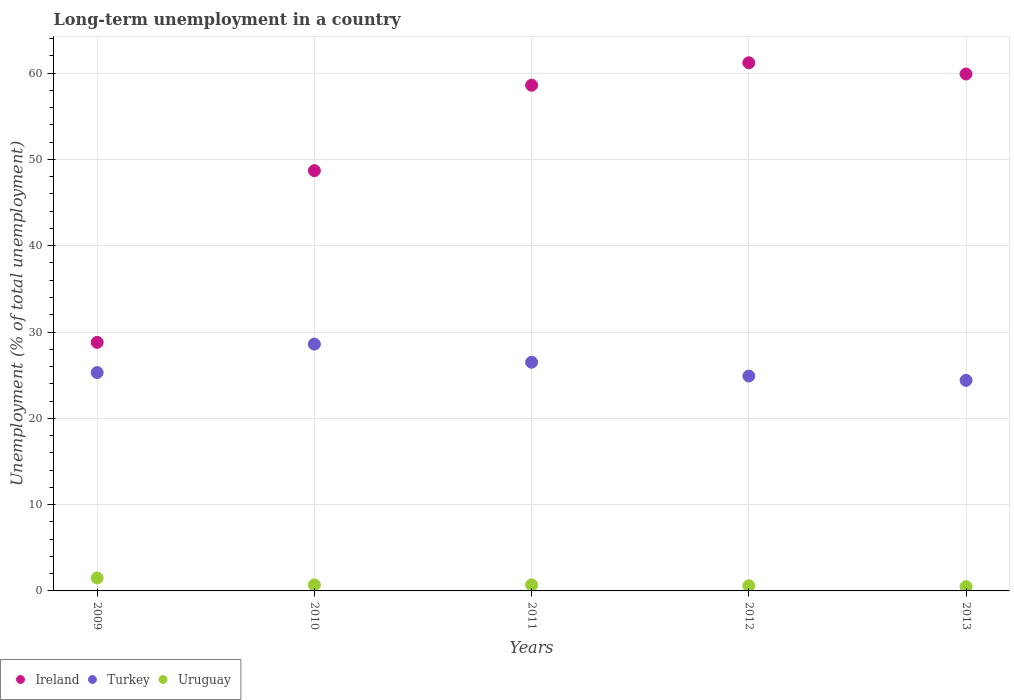What is the percentage of long-term unemployed population in Ireland in 2013?
Offer a very short reply. 59.9. Across all years, what is the maximum percentage of long-term unemployed population in Turkey?
Provide a short and direct response. 28.6. Across all years, what is the minimum percentage of long-term unemployed population in Ireland?
Your answer should be compact. 28.8. In which year was the percentage of long-term unemployed population in Turkey maximum?
Provide a short and direct response. 2010. In which year was the percentage of long-term unemployed population in Uruguay minimum?
Keep it short and to the point. 2013. What is the total percentage of long-term unemployed population in Ireland in the graph?
Ensure brevity in your answer.  257.2. What is the difference between the percentage of long-term unemployed population in Turkey in 2009 and that in 2010?
Keep it short and to the point. -3.3. What is the difference between the percentage of long-term unemployed population in Turkey in 2013 and the percentage of long-term unemployed population in Uruguay in 2010?
Provide a short and direct response. 23.7. What is the average percentage of long-term unemployed population in Turkey per year?
Give a very brief answer. 25.94. In the year 2013, what is the difference between the percentage of long-term unemployed population in Ireland and percentage of long-term unemployed population in Uruguay?
Keep it short and to the point. 59.4. What is the ratio of the percentage of long-term unemployed population in Ireland in 2011 to that in 2013?
Provide a succinct answer. 0.98. Is the percentage of long-term unemployed population in Uruguay in 2011 less than that in 2012?
Make the answer very short. No. Is the difference between the percentage of long-term unemployed population in Ireland in 2009 and 2011 greater than the difference between the percentage of long-term unemployed population in Uruguay in 2009 and 2011?
Provide a short and direct response. No. What is the difference between the highest and the second highest percentage of long-term unemployed population in Ireland?
Your response must be concise. 1.3. What is the difference between the highest and the lowest percentage of long-term unemployed population in Turkey?
Give a very brief answer. 4.2. In how many years, is the percentage of long-term unemployed population in Turkey greater than the average percentage of long-term unemployed population in Turkey taken over all years?
Give a very brief answer. 2. Is it the case that in every year, the sum of the percentage of long-term unemployed population in Ireland and percentage of long-term unemployed population in Uruguay  is greater than the percentage of long-term unemployed population in Turkey?
Give a very brief answer. Yes. Is the percentage of long-term unemployed population in Uruguay strictly greater than the percentage of long-term unemployed population in Ireland over the years?
Make the answer very short. No. How many dotlines are there?
Offer a very short reply. 3. How many years are there in the graph?
Offer a terse response. 5. Are the values on the major ticks of Y-axis written in scientific E-notation?
Offer a very short reply. No. Does the graph contain any zero values?
Give a very brief answer. No. Does the graph contain grids?
Give a very brief answer. Yes. How many legend labels are there?
Your answer should be very brief. 3. What is the title of the graph?
Offer a terse response. Long-term unemployment in a country. What is the label or title of the X-axis?
Offer a very short reply. Years. What is the label or title of the Y-axis?
Offer a terse response. Unemployment (% of total unemployment). What is the Unemployment (% of total unemployment) in Ireland in 2009?
Your response must be concise. 28.8. What is the Unemployment (% of total unemployment) in Turkey in 2009?
Your response must be concise. 25.3. What is the Unemployment (% of total unemployment) in Ireland in 2010?
Keep it short and to the point. 48.7. What is the Unemployment (% of total unemployment) in Turkey in 2010?
Provide a succinct answer. 28.6. What is the Unemployment (% of total unemployment) in Uruguay in 2010?
Ensure brevity in your answer.  0.7. What is the Unemployment (% of total unemployment) of Ireland in 2011?
Make the answer very short. 58.6. What is the Unemployment (% of total unemployment) in Uruguay in 2011?
Give a very brief answer. 0.7. What is the Unemployment (% of total unemployment) of Ireland in 2012?
Give a very brief answer. 61.2. What is the Unemployment (% of total unemployment) in Turkey in 2012?
Keep it short and to the point. 24.9. What is the Unemployment (% of total unemployment) in Uruguay in 2012?
Offer a terse response. 0.6. What is the Unemployment (% of total unemployment) in Ireland in 2013?
Your answer should be very brief. 59.9. What is the Unemployment (% of total unemployment) in Turkey in 2013?
Offer a very short reply. 24.4. Across all years, what is the maximum Unemployment (% of total unemployment) in Ireland?
Keep it short and to the point. 61.2. Across all years, what is the maximum Unemployment (% of total unemployment) in Turkey?
Your response must be concise. 28.6. Across all years, what is the maximum Unemployment (% of total unemployment) of Uruguay?
Give a very brief answer. 1.5. Across all years, what is the minimum Unemployment (% of total unemployment) of Ireland?
Ensure brevity in your answer.  28.8. Across all years, what is the minimum Unemployment (% of total unemployment) in Turkey?
Offer a terse response. 24.4. What is the total Unemployment (% of total unemployment) of Ireland in the graph?
Offer a very short reply. 257.2. What is the total Unemployment (% of total unemployment) in Turkey in the graph?
Offer a very short reply. 129.7. What is the total Unemployment (% of total unemployment) in Uruguay in the graph?
Provide a succinct answer. 4. What is the difference between the Unemployment (% of total unemployment) in Ireland in 2009 and that in 2010?
Provide a short and direct response. -19.9. What is the difference between the Unemployment (% of total unemployment) of Ireland in 2009 and that in 2011?
Offer a terse response. -29.8. What is the difference between the Unemployment (% of total unemployment) of Turkey in 2009 and that in 2011?
Your response must be concise. -1.2. What is the difference between the Unemployment (% of total unemployment) in Ireland in 2009 and that in 2012?
Provide a short and direct response. -32.4. What is the difference between the Unemployment (% of total unemployment) of Ireland in 2009 and that in 2013?
Keep it short and to the point. -31.1. What is the difference between the Unemployment (% of total unemployment) in Ireland in 2010 and that in 2011?
Offer a terse response. -9.9. What is the difference between the Unemployment (% of total unemployment) of Ireland in 2010 and that in 2013?
Provide a succinct answer. -11.2. What is the difference between the Unemployment (% of total unemployment) of Turkey in 2010 and that in 2013?
Your answer should be very brief. 4.2. What is the difference between the Unemployment (% of total unemployment) in Turkey in 2011 and that in 2012?
Your answer should be compact. 1.6. What is the difference between the Unemployment (% of total unemployment) of Uruguay in 2011 and that in 2012?
Provide a short and direct response. 0.1. What is the difference between the Unemployment (% of total unemployment) of Ireland in 2011 and that in 2013?
Keep it short and to the point. -1.3. What is the difference between the Unemployment (% of total unemployment) in Turkey in 2011 and that in 2013?
Your response must be concise. 2.1. What is the difference between the Unemployment (% of total unemployment) in Uruguay in 2011 and that in 2013?
Give a very brief answer. 0.2. What is the difference between the Unemployment (% of total unemployment) of Turkey in 2012 and that in 2013?
Make the answer very short. 0.5. What is the difference between the Unemployment (% of total unemployment) of Ireland in 2009 and the Unemployment (% of total unemployment) of Uruguay in 2010?
Provide a succinct answer. 28.1. What is the difference between the Unemployment (% of total unemployment) of Turkey in 2009 and the Unemployment (% of total unemployment) of Uruguay in 2010?
Make the answer very short. 24.6. What is the difference between the Unemployment (% of total unemployment) of Ireland in 2009 and the Unemployment (% of total unemployment) of Uruguay in 2011?
Provide a short and direct response. 28.1. What is the difference between the Unemployment (% of total unemployment) of Turkey in 2009 and the Unemployment (% of total unemployment) of Uruguay in 2011?
Your answer should be very brief. 24.6. What is the difference between the Unemployment (% of total unemployment) in Ireland in 2009 and the Unemployment (% of total unemployment) in Uruguay in 2012?
Make the answer very short. 28.2. What is the difference between the Unemployment (% of total unemployment) of Turkey in 2009 and the Unemployment (% of total unemployment) of Uruguay in 2012?
Make the answer very short. 24.7. What is the difference between the Unemployment (% of total unemployment) in Ireland in 2009 and the Unemployment (% of total unemployment) in Turkey in 2013?
Provide a succinct answer. 4.4. What is the difference between the Unemployment (% of total unemployment) in Ireland in 2009 and the Unemployment (% of total unemployment) in Uruguay in 2013?
Offer a very short reply. 28.3. What is the difference between the Unemployment (% of total unemployment) in Turkey in 2009 and the Unemployment (% of total unemployment) in Uruguay in 2013?
Provide a succinct answer. 24.8. What is the difference between the Unemployment (% of total unemployment) of Turkey in 2010 and the Unemployment (% of total unemployment) of Uruguay in 2011?
Provide a short and direct response. 27.9. What is the difference between the Unemployment (% of total unemployment) in Ireland in 2010 and the Unemployment (% of total unemployment) in Turkey in 2012?
Provide a short and direct response. 23.8. What is the difference between the Unemployment (% of total unemployment) in Ireland in 2010 and the Unemployment (% of total unemployment) in Uruguay in 2012?
Make the answer very short. 48.1. What is the difference between the Unemployment (% of total unemployment) of Ireland in 2010 and the Unemployment (% of total unemployment) of Turkey in 2013?
Your response must be concise. 24.3. What is the difference between the Unemployment (% of total unemployment) in Ireland in 2010 and the Unemployment (% of total unemployment) in Uruguay in 2013?
Provide a succinct answer. 48.2. What is the difference between the Unemployment (% of total unemployment) of Turkey in 2010 and the Unemployment (% of total unemployment) of Uruguay in 2013?
Provide a short and direct response. 28.1. What is the difference between the Unemployment (% of total unemployment) in Ireland in 2011 and the Unemployment (% of total unemployment) in Turkey in 2012?
Your response must be concise. 33.7. What is the difference between the Unemployment (% of total unemployment) of Ireland in 2011 and the Unemployment (% of total unemployment) of Uruguay in 2012?
Give a very brief answer. 58. What is the difference between the Unemployment (% of total unemployment) of Turkey in 2011 and the Unemployment (% of total unemployment) of Uruguay in 2012?
Provide a succinct answer. 25.9. What is the difference between the Unemployment (% of total unemployment) in Ireland in 2011 and the Unemployment (% of total unemployment) in Turkey in 2013?
Make the answer very short. 34.2. What is the difference between the Unemployment (% of total unemployment) of Ireland in 2011 and the Unemployment (% of total unemployment) of Uruguay in 2013?
Offer a terse response. 58.1. What is the difference between the Unemployment (% of total unemployment) in Turkey in 2011 and the Unemployment (% of total unemployment) in Uruguay in 2013?
Your response must be concise. 26. What is the difference between the Unemployment (% of total unemployment) in Ireland in 2012 and the Unemployment (% of total unemployment) in Turkey in 2013?
Provide a short and direct response. 36.8. What is the difference between the Unemployment (% of total unemployment) of Ireland in 2012 and the Unemployment (% of total unemployment) of Uruguay in 2013?
Ensure brevity in your answer.  60.7. What is the difference between the Unemployment (% of total unemployment) in Turkey in 2012 and the Unemployment (% of total unemployment) in Uruguay in 2013?
Your response must be concise. 24.4. What is the average Unemployment (% of total unemployment) in Ireland per year?
Your response must be concise. 51.44. What is the average Unemployment (% of total unemployment) in Turkey per year?
Offer a terse response. 25.94. What is the average Unemployment (% of total unemployment) of Uruguay per year?
Your answer should be very brief. 0.8. In the year 2009, what is the difference between the Unemployment (% of total unemployment) of Ireland and Unemployment (% of total unemployment) of Turkey?
Give a very brief answer. 3.5. In the year 2009, what is the difference between the Unemployment (% of total unemployment) in Ireland and Unemployment (% of total unemployment) in Uruguay?
Keep it short and to the point. 27.3. In the year 2009, what is the difference between the Unemployment (% of total unemployment) in Turkey and Unemployment (% of total unemployment) in Uruguay?
Ensure brevity in your answer.  23.8. In the year 2010, what is the difference between the Unemployment (% of total unemployment) in Ireland and Unemployment (% of total unemployment) in Turkey?
Provide a succinct answer. 20.1. In the year 2010, what is the difference between the Unemployment (% of total unemployment) of Ireland and Unemployment (% of total unemployment) of Uruguay?
Provide a succinct answer. 48. In the year 2010, what is the difference between the Unemployment (% of total unemployment) in Turkey and Unemployment (% of total unemployment) in Uruguay?
Ensure brevity in your answer.  27.9. In the year 2011, what is the difference between the Unemployment (% of total unemployment) in Ireland and Unemployment (% of total unemployment) in Turkey?
Ensure brevity in your answer.  32.1. In the year 2011, what is the difference between the Unemployment (% of total unemployment) of Ireland and Unemployment (% of total unemployment) of Uruguay?
Your answer should be compact. 57.9. In the year 2011, what is the difference between the Unemployment (% of total unemployment) of Turkey and Unemployment (% of total unemployment) of Uruguay?
Keep it short and to the point. 25.8. In the year 2012, what is the difference between the Unemployment (% of total unemployment) in Ireland and Unemployment (% of total unemployment) in Turkey?
Keep it short and to the point. 36.3. In the year 2012, what is the difference between the Unemployment (% of total unemployment) in Ireland and Unemployment (% of total unemployment) in Uruguay?
Your response must be concise. 60.6. In the year 2012, what is the difference between the Unemployment (% of total unemployment) of Turkey and Unemployment (% of total unemployment) of Uruguay?
Provide a short and direct response. 24.3. In the year 2013, what is the difference between the Unemployment (% of total unemployment) in Ireland and Unemployment (% of total unemployment) in Turkey?
Provide a succinct answer. 35.5. In the year 2013, what is the difference between the Unemployment (% of total unemployment) of Ireland and Unemployment (% of total unemployment) of Uruguay?
Make the answer very short. 59.4. In the year 2013, what is the difference between the Unemployment (% of total unemployment) in Turkey and Unemployment (% of total unemployment) in Uruguay?
Give a very brief answer. 23.9. What is the ratio of the Unemployment (% of total unemployment) of Ireland in 2009 to that in 2010?
Offer a very short reply. 0.59. What is the ratio of the Unemployment (% of total unemployment) in Turkey in 2009 to that in 2010?
Your answer should be compact. 0.88. What is the ratio of the Unemployment (% of total unemployment) of Uruguay in 2009 to that in 2010?
Give a very brief answer. 2.14. What is the ratio of the Unemployment (% of total unemployment) of Ireland in 2009 to that in 2011?
Provide a short and direct response. 0.49. What is the ratio of the Unemployment (% of total unemployment) of Turkey in 2009 to that in 2011?
Provide a short and direct response. 0.95. What is the ratio of the Unemployment (% of total unemployment) of Uruguay in 2009 to that in 2011?
Keep it short and to the point. 2.14. What is the ratio of the Unemployment (% of total unemployment) in Ireland in 2009 to that in 2012?
Offer a very short reply. 0.47. What is the ratio of the Unemployment (% of total unemployment) in Turkey in 2009 to that in 2012?
Give a very brief answer. 1.02. What is the ratio of the Unemployment (% of total unemployment) of Ireland in 2009 to that in 2013?
Make the answer very short. 0.48. What is the ratio of the Unemployment (% of total unemployment) of Turkey in 2009 to that in 2013?
Make the answer very short. 1.04. What is the ratio of the Unemployment (% of total unemployment) in Ireland in 2010 to that in 2011?
Provide a succinct answer. 0.83. What is the ratio of the Unemployment (% of total unemployment) of Turkey in 2010 to that in 2011?
Make the answer very short. 1.08. What is the ratio of the Unemployment (% of total unemployment) in Ireland in 2010 to that in 2012?
Offer a terse response. 0.8. What is the ratio of the Unemployment (% of total unemployment) in Turkey in 2010 to that in 2012?
Ensure brevity in your answer.  1.15. What is the ratio of the Unemployment (% of total unemployment) of Ireland in 2010 to that in 2013?
Offer a very short reply. 0.81. What is the ratio of the Unemployment (% of total unemployment) of Turkey in 2010 to that in 2013?
Offer a very short reply. 1.17. What is the ratio of the Unemployment (% of total unemployment) of Ireland in 2011 to that in 2012?
Provide a succinct answer. 0.96. What is the ratio of the Unemployment (% of total unemployment) in Turkey in 2011 to that in 2012?
Your answer should be very brief. 1.06. What is the ratio of the Unemployment (% of total unemployment) of Uruguay in 2011 to that in 2012?
Keep it short and to the point. 1.17. What is the ratio of the Unemployment (% of total unemployment) in Ireland in 2011 to that in 2013?
Your answer should be compact. 0.98. What is the ratio of the Unemployment (% of total unemployment) of Turkey in 2011 to that in 2013?
Give a very brief answer. 1.09. What is the ratio of the Unemployment (% of total unemployment) of Ireland in 2012 to that in 2013?
Make the answer very short. 1.02. What is the ratio of the Unemployment (% of total unemployment) of Turkey in 2012 to that in 2013?
Your answer should be compact. 1.02. What is the difference between the highest and the second highest Unemployment (% of total unemployment) in Ireland?
Your answer should be compact. 1.3. What is the difference between the highest and the second highest Unemployment (% of total unemployment) of Uruguay?
Keep it short and to the point. 0.8. What is the difference between the highest and the lowest Unemployment (% of total unemployment) of Ireland?
Provide a short and direct response. 32.4. What is the difference between the highest and the lowest Unemployment (% of total unemployment) of Uruguay?
Your answer should be compact. 1. 